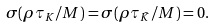Convert formula to latex. <formula><loc_0><loc_0><loc_500><loc_500>\sigma ( \rho \tau _ { K } / M ) = \sigma ( \rho \tau _ { \bar { K } } / M ) = 0 .</formula> 